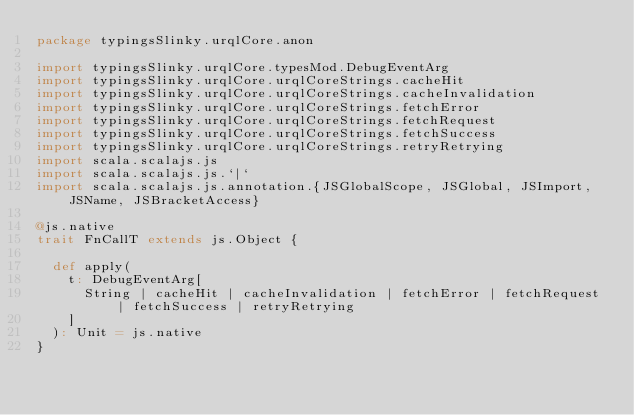<code> <loc_0><loc_0><loc_500><loc_500><_Scala_>package typingsSlinky.urqlCore.anon

import typingsSlinky.urqlCore.typesMod.DebugEventArg
import typingsSlinky.urqlCore.urqlCoreStrings.cacheHit
import typingsSlinky.urqlCore.urqlCoreStrings.cacheInvalidation
import typingsSlinky.urqlCore.urqlCoreStrings.fetchError
import typingsSlinky.urqlCore.urqlCoreStrings.fetchRequest
import typingsSlinky.urqlCore.urqlCoreStrings.fetchSuccess
import typingsSlinky.urqlCore.urqlCoreStrings.retryRetrying
import scala.scalajs.js
import scala.scalajs.js.`|`
import scala.scalajs.js.annotation.{JSGlobalScope, JSGlobal, JSImport, JSName, JSBracketAccess}

@js.native
trait FnCallT extends js.Object {
  
  def apply(
    t: DebugEventArg[
      String | cacheHit | cacheInvalidation | fetchError | fetchRequest | fetchSuccess | retryRetrying
    ]
  ): Unit = js.native
}
</code> 